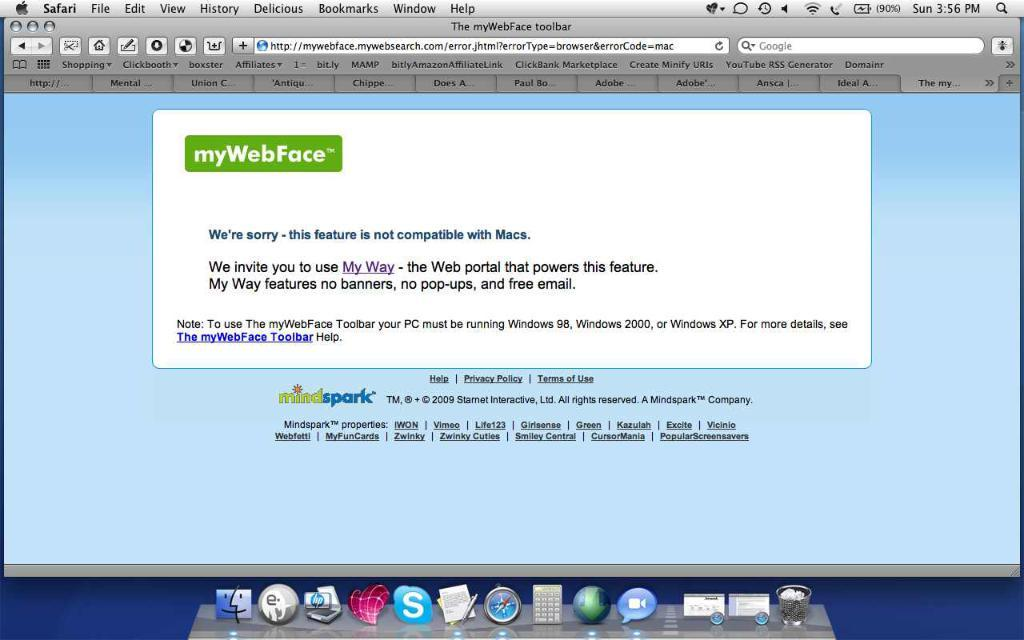<image>
Describe the image concisely. mywebface is opened on the web browser of the computer 